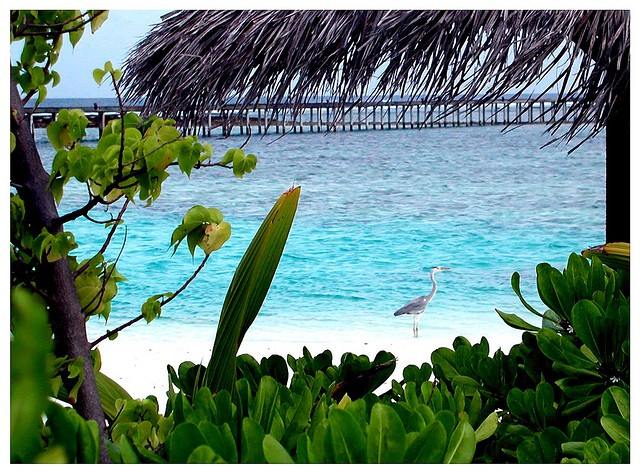Describe the objects in this image and their specific colors. I can see a bird in white, darkgray, lightgray, gray, and lightblue tones in this image. 